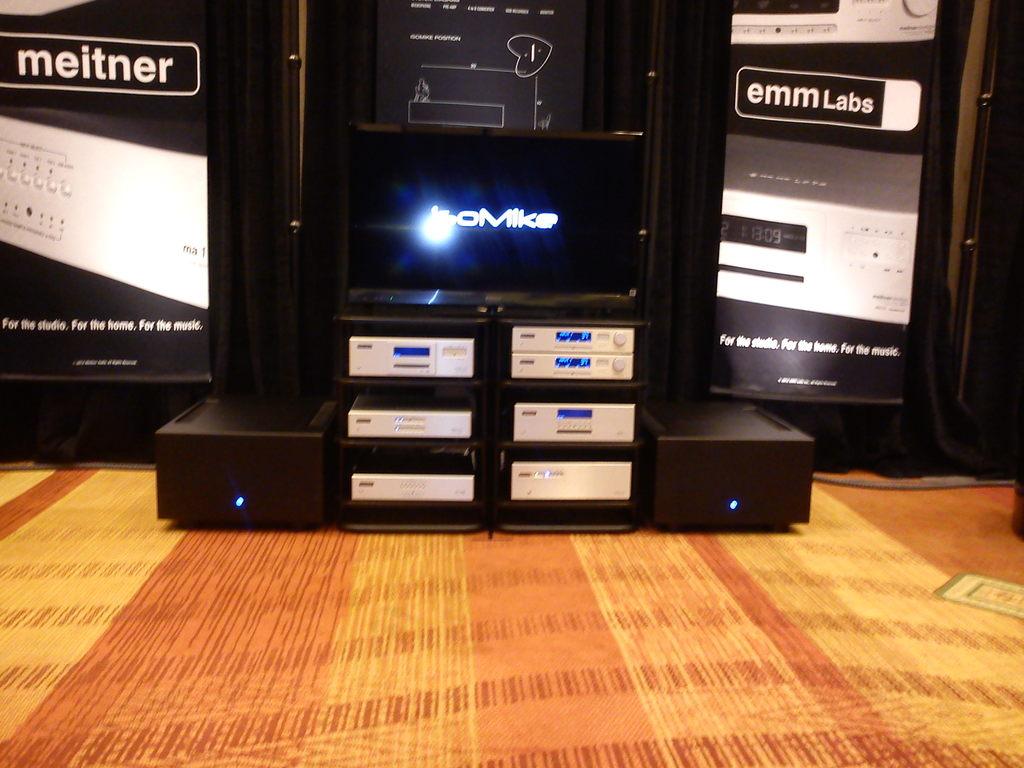What is the brand name to the left?
Ensure brevity in your answer.  Meitner. 